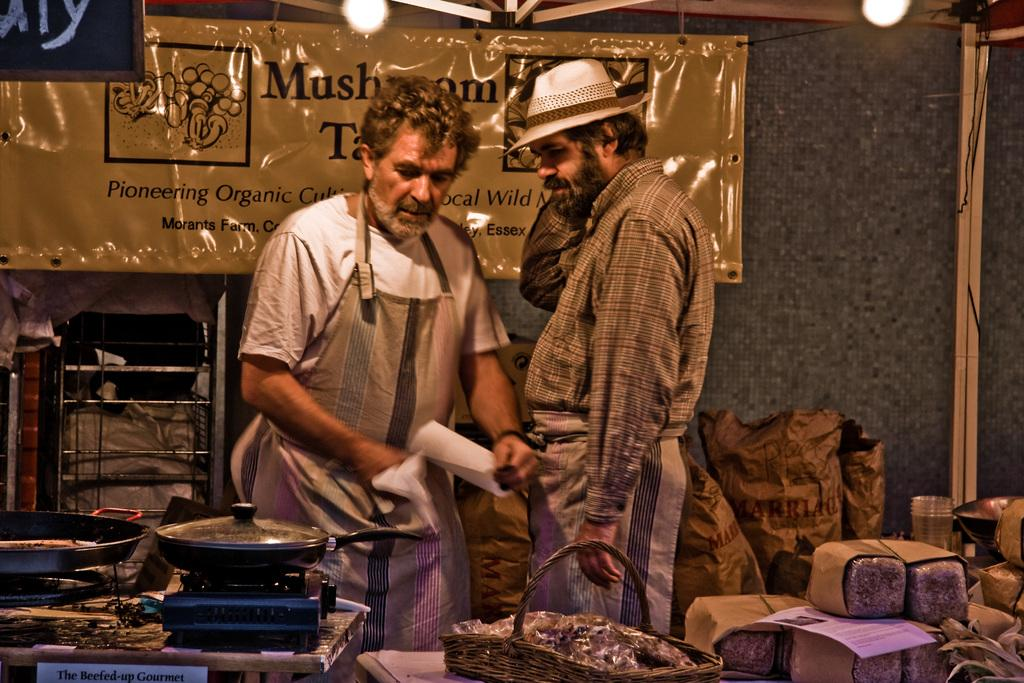How many people are in the image? There are two persons standing in the image. What can be seen in the image related to cooking? There is a gas stove and non-stick pans in the image. What object is used for holding items in the image? There is a basket in the image. What type of items are present in the image? There are food items in the image. What is the source of illumination in the image? There are lights in the image. What is written or displayed on the board in the background of the image? There is a board with text in the background of the image. How many sacks are being carried by the persons in the image? There are no sacks visible in the image; only two persons, a gas stove, non-stick pans, a basket, food items, lights, and a board with text are present. Can you see any frogs in the image? There are no frogs present in the image. 